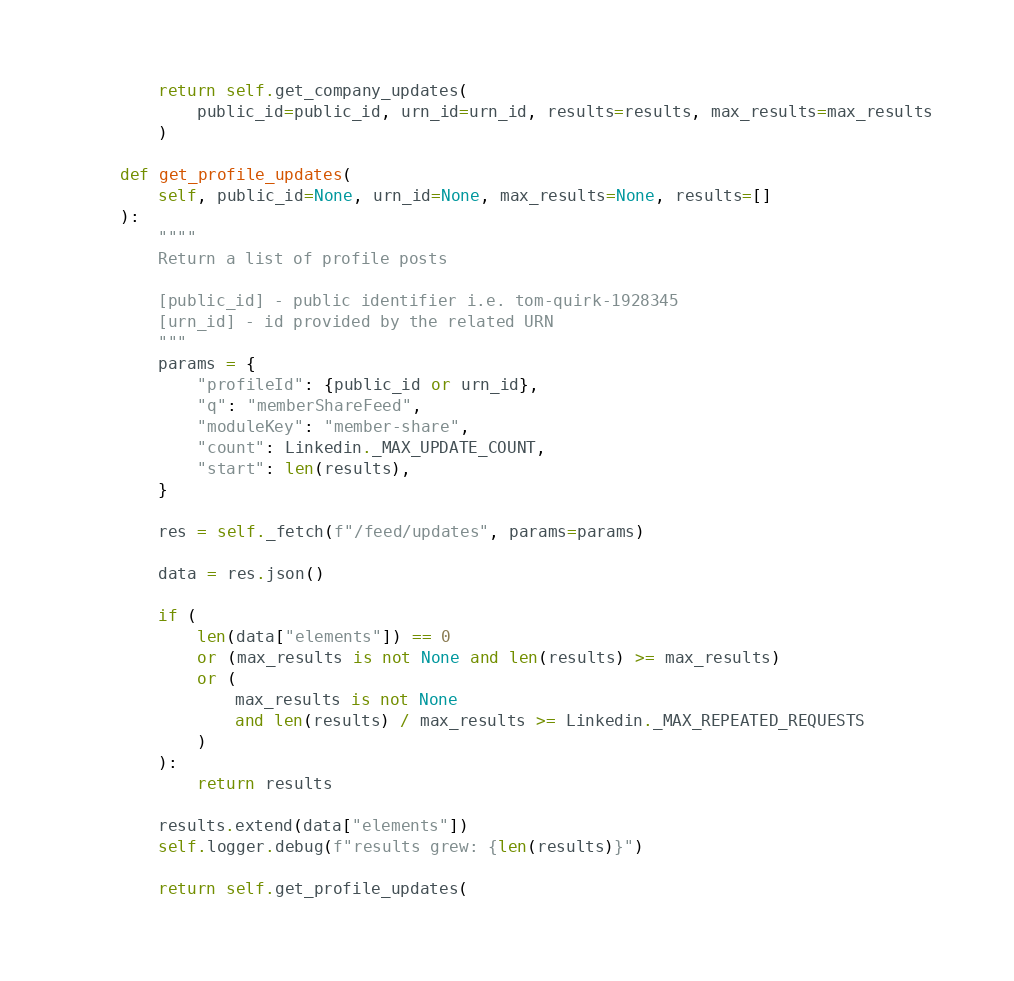<code> <loc_0><loc_0><loc_500><loc_500><_Python_>        return self.get_company_updates(
            public_id=public_id, urn_id=urn_id, results=results, max_results=max_results
        )

    def get_profile_updates(
        self, public_id=None, urn_id=None, max_results=None, results=[]
    ):
        """"
        Return a list of profile posts

        [public_id] - public identifier i.e. tom-quirk-1928345
        [urn_id] - id provided by the related URN
        """
        params = {
            "profileId": {public_id or urn_id},
            "q": "memberShareFeed",
            "moduleKey": "member-share",
            "count": Linkedin._MAX_UPDATE_COUNT,
            "start": len(results),
        }

        res = self._fetch(f"/feed/updates", params=params)

        data = res.json()

        if (
            len(data["elements"]) == 0
            or (max_results is not None and len(results) >= max_results)
            or (
                max_results is not None
                and len(results) / max_results >= Linkedin._MAX_REPEATED_REQUESTS
            )
        ):
            return results

        results.extend(data["elements"])
        self.logger.debug(f"results grew: {len(results)}")

        return self.get_profile_updates(</code> 